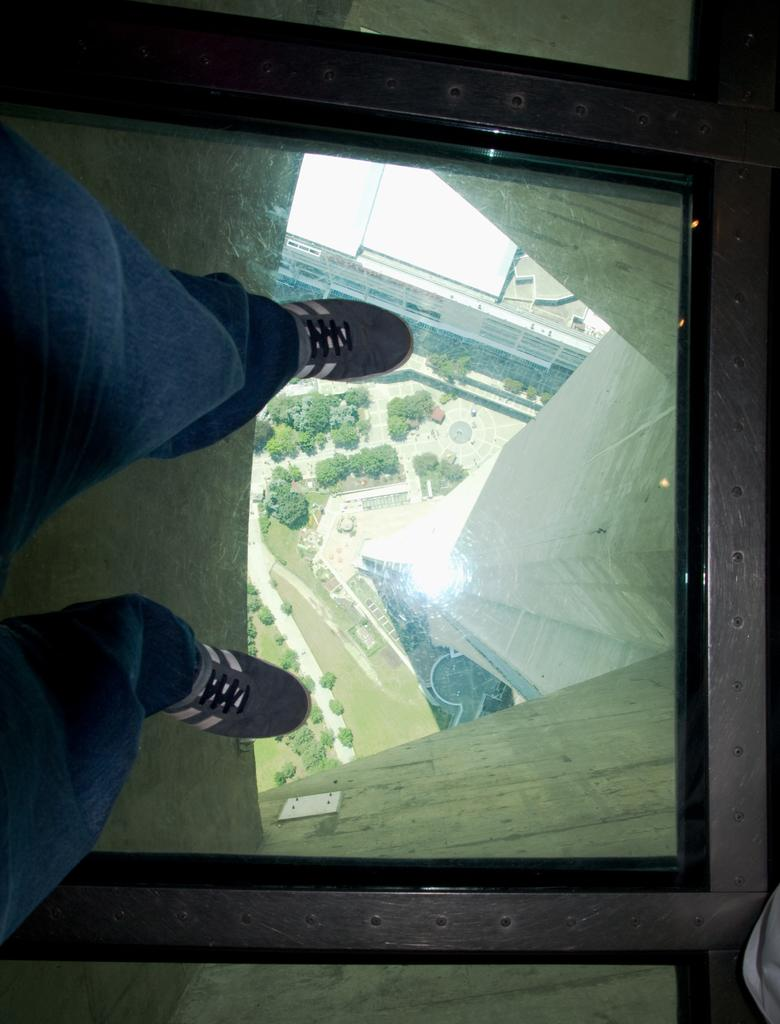What is the position of the person in the image? The person is standing on the left side of the image. What surface is the person standing on? The person is standing on glass. What can be seen through the glass? Trees and a road are visible through the glass. What type of balloon is the boy holding in the image? There is no balloon or boy present in the image; it only features a person standing on glass with trees and a road visible through it. 